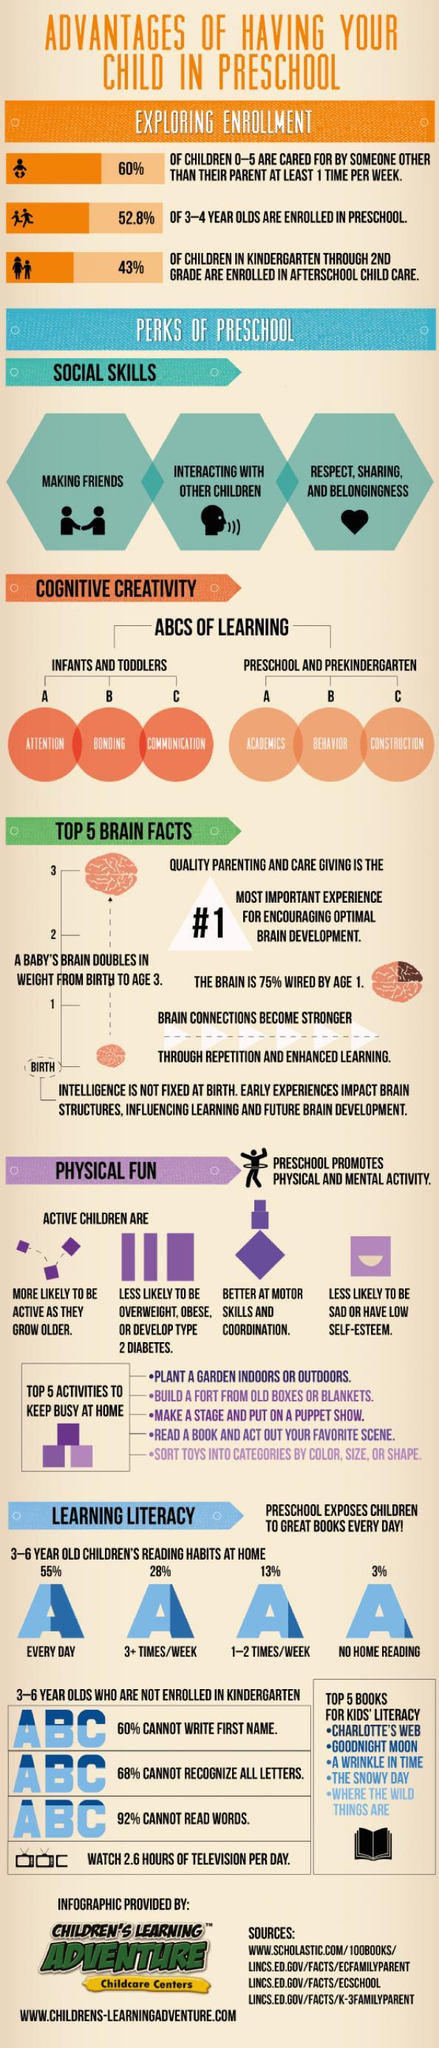What % of children read 1-2 times/week
Answer the question with a short phrase. 13 who are likely to be active as they grow olders active children how many social skills are developed from preschool 3 what is the colour of the book image, white or black black how many years does it take for the bab's brain to double 3 